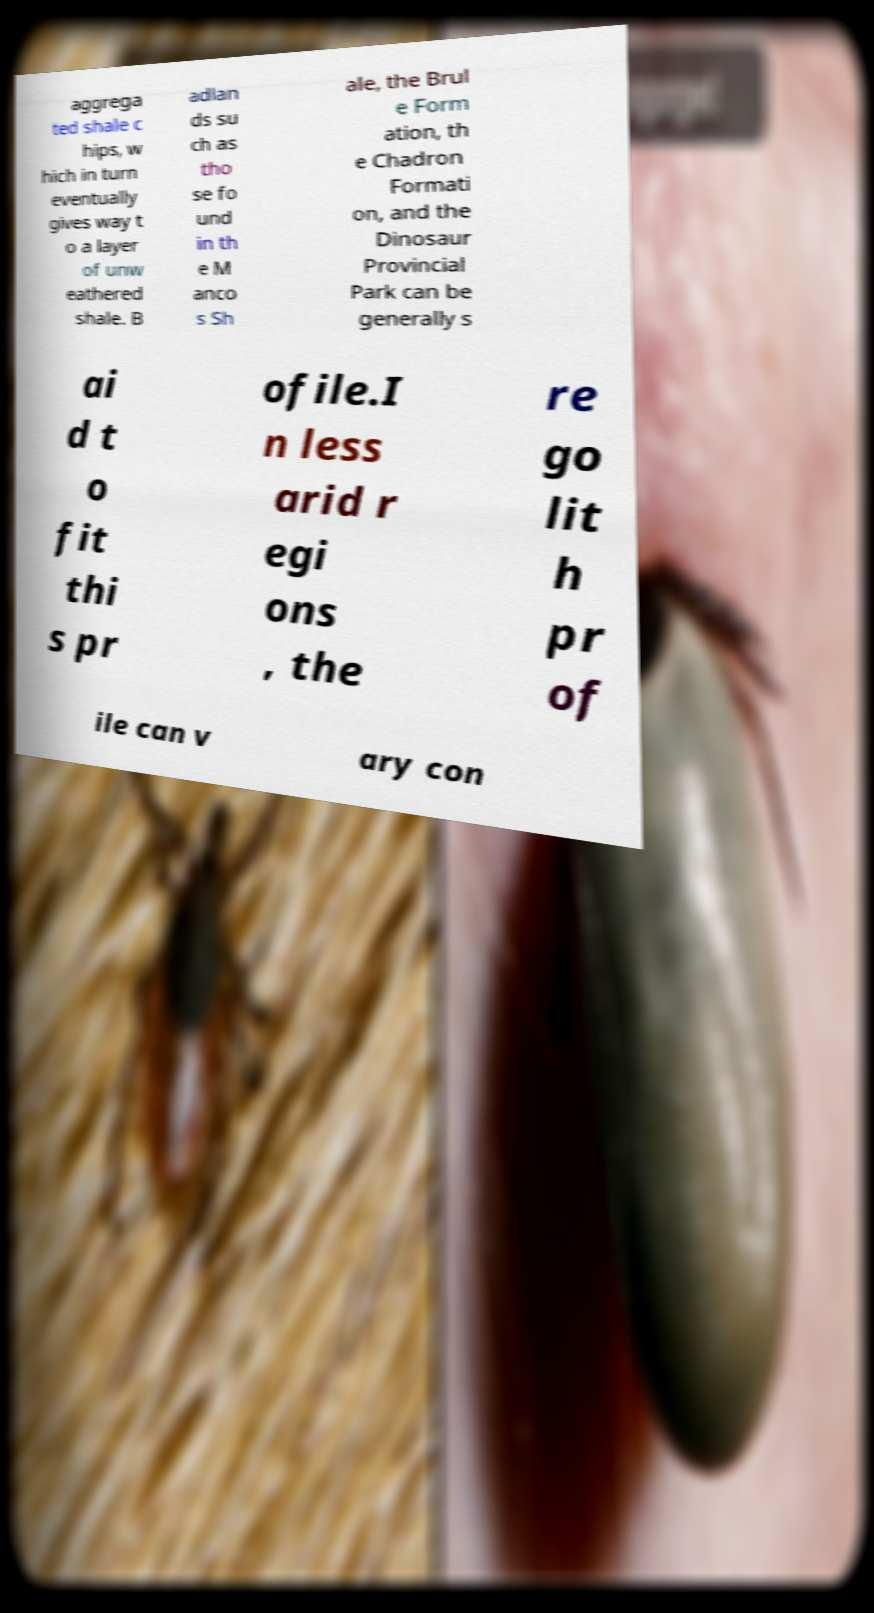Can you read and provide the text displayed in the image?This photo seems to have some interesting text. Can you extract and type it out for me? aggrega ted shale c hips, w hich in turn eventually gives way t o a layer of unw eathered shale. B adlan ds su ch as tho se fo und in th e M anco s Sh ale, the Brul e Form ation, th e Chadron Formati on, and the Dinosaur Provincial Park can be generally s ai d t o fit thi s pr ofile.I n less arid r egi ons , the re go lit h pr of ile can v ary con 